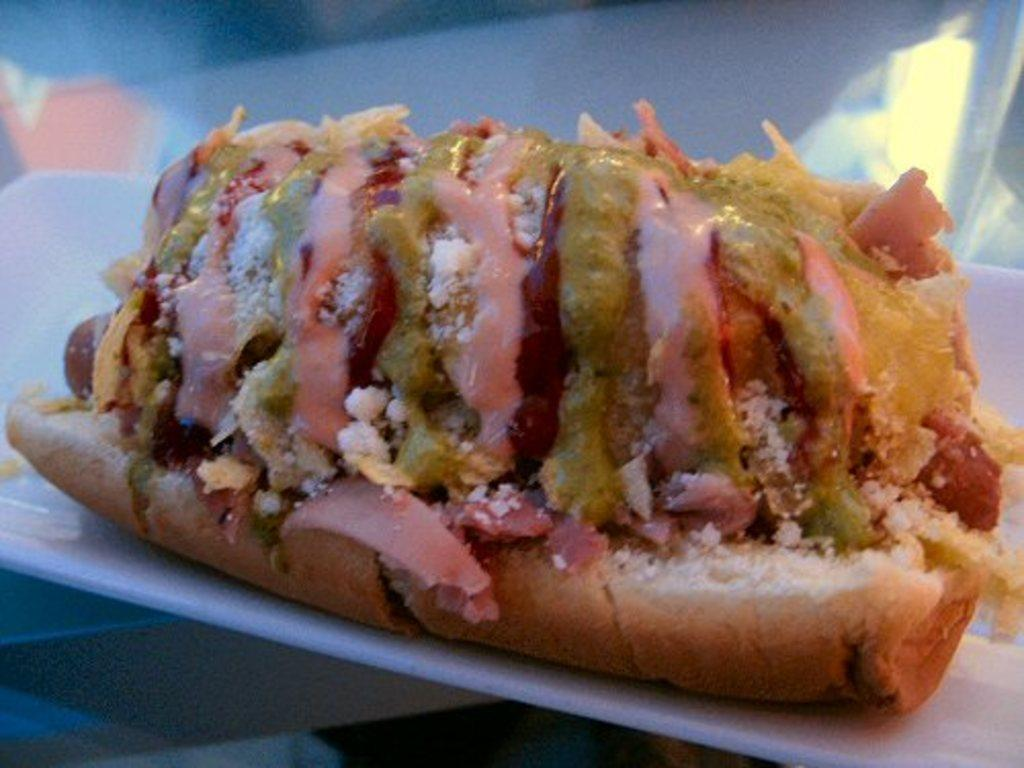What is on the plate that is visible in the image? There is food on a plate in the image. What can be seen in the background of the image? There is a table in the background of the image. What type of bird can be seen building a cobweb in the image? There is no bird or cobweb present in the image; it only features food on a plate and a table in the background. 